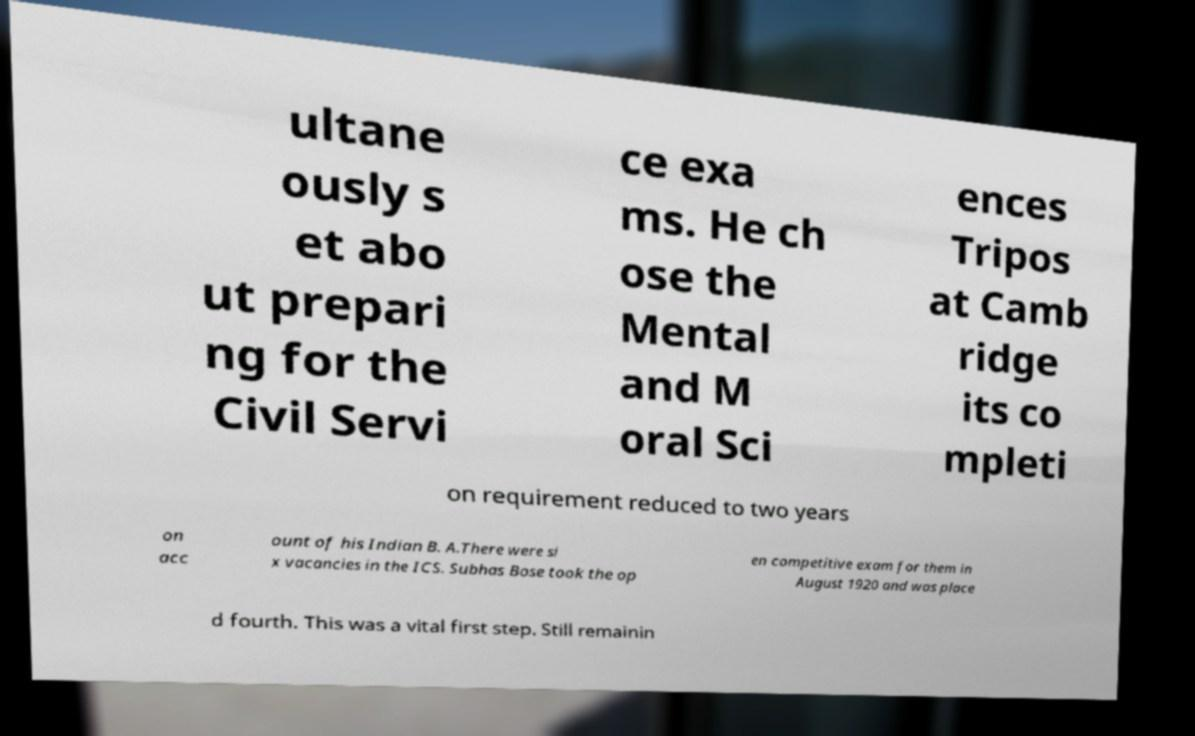For documentation purposes, I need the text within this image transcribed. Could you provide that? ultane ously s et abo ut prepari ng for the Civil Servi ce exa ms. He ch ose the Mental and M oral Sci ences Tripos at Camb ridge its co mpleti on requirement reduced to two years on acc ount of his Indian B. A.There were si x vacancies in the ICS. Subhas Bose took the op en competitive exam for them in August 1920 and was place d fourth. This was a vital first step. Still remainin 